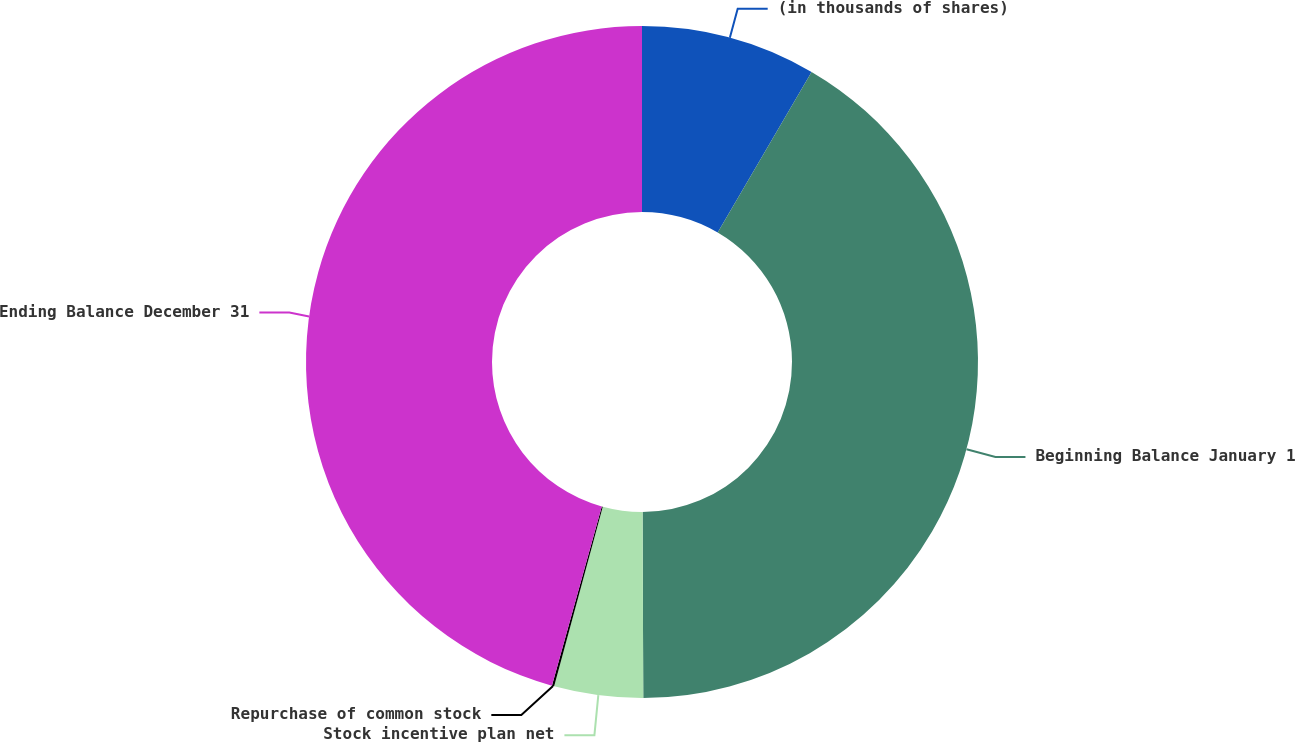<chart> <loc_0><loc_0><loc_500><loc_500><pie_chart><fcel>(in thousands of shares)<fcel>Beginning Balance January 1<fcel>Stock incentive plan net<fcel>Repurchase of common stock<fcel>Ending Balance December 31<nl><fcel>8.42%<fcel>41.52%<fcel>4.27%<fcel>0.11%<fcel>45.68%<nl></chart> 